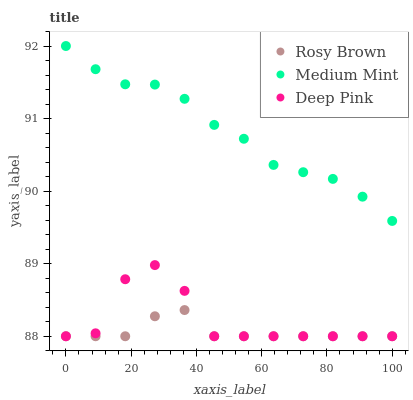Does Rosy Brown have the minimum area under the curve?
Answer yes or no. Yes. Does Medium Mint have the maximum area under the curve?
Answer yes or no. Yes. Does Deep Pink have the minimum area under the curve?
Answer yes or no. No. Does Deep Pink have the maximum area under the curve?
Answer yes or no. No. Is Rosy Brown the smoothest?
Answer yes or no. Yes. Is Deep Pink the roughest?
Answer yes or no. Yes. Is Deep Pink the smoothest?
Answer yes or no. No. Is Rosy Brown the roughest?
Answer yes or no. No. Does Rosy Brown have the lowest value?
Answer yes or no. Yes. Does Medium Mint have the highest value?
Answer yes or no. Yes. Does Deep Pink have the highest value?
Answer yes or no. No. Is Rosy Brown less than Medium Mint?
Answer yes or no. Yes. Is Medium Mint greater than Rosy Brown?
Answer yes or no. Yes. Does Rosy Brown intersect Deep Pink?
Answer yes or no. Yes. Is Rosy Brown less than Deep Pink?
Answer yes or no. No. Is Rosy Brown greater than Deep Pink?
Answer yes or no. No. Does Rosy Brown intersect Medium Mint?
Answer yes or no. No. 